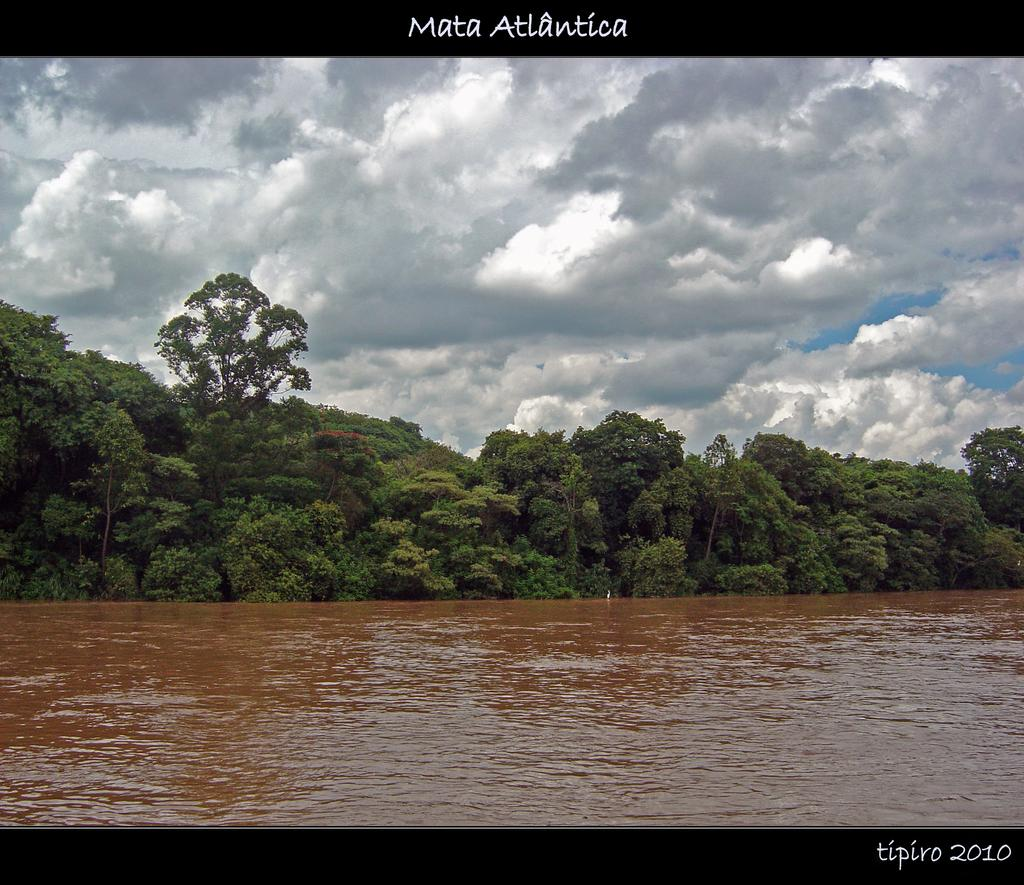What body of water is visible in the image? There is a lake in the image. What type of vegetation is near the lake? There are trees beside the lake in the image. Where is the banana located in the image? There is no banana present in the image. What type of store can be seen near the lake in the image? There is no store visible in the image; it only features a lake and trees. 